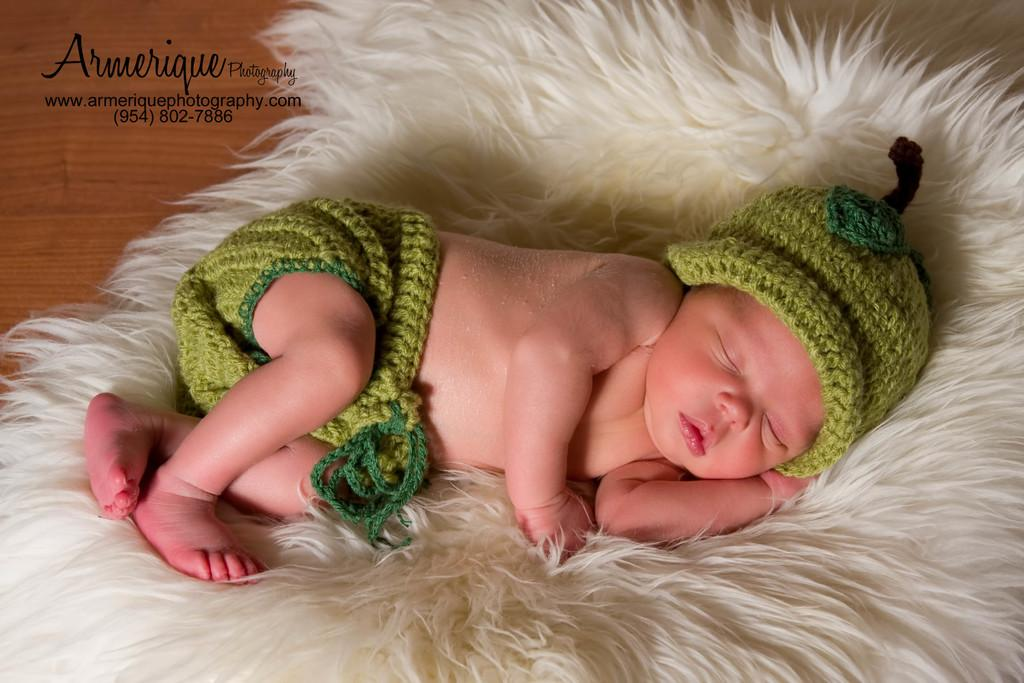What is the main subject of the image? The main subject of the image is a baby sleeping. What is the baby lying on? The baby is on a fur. Is there any text present in the image? Yes, there is text in the top left corner of the image. What grade is the baby in, and how did they perform on their last math test? There is no indication of the baby's grade or their performance on a math test in the image, as it features a baby sleeping on a fur. 